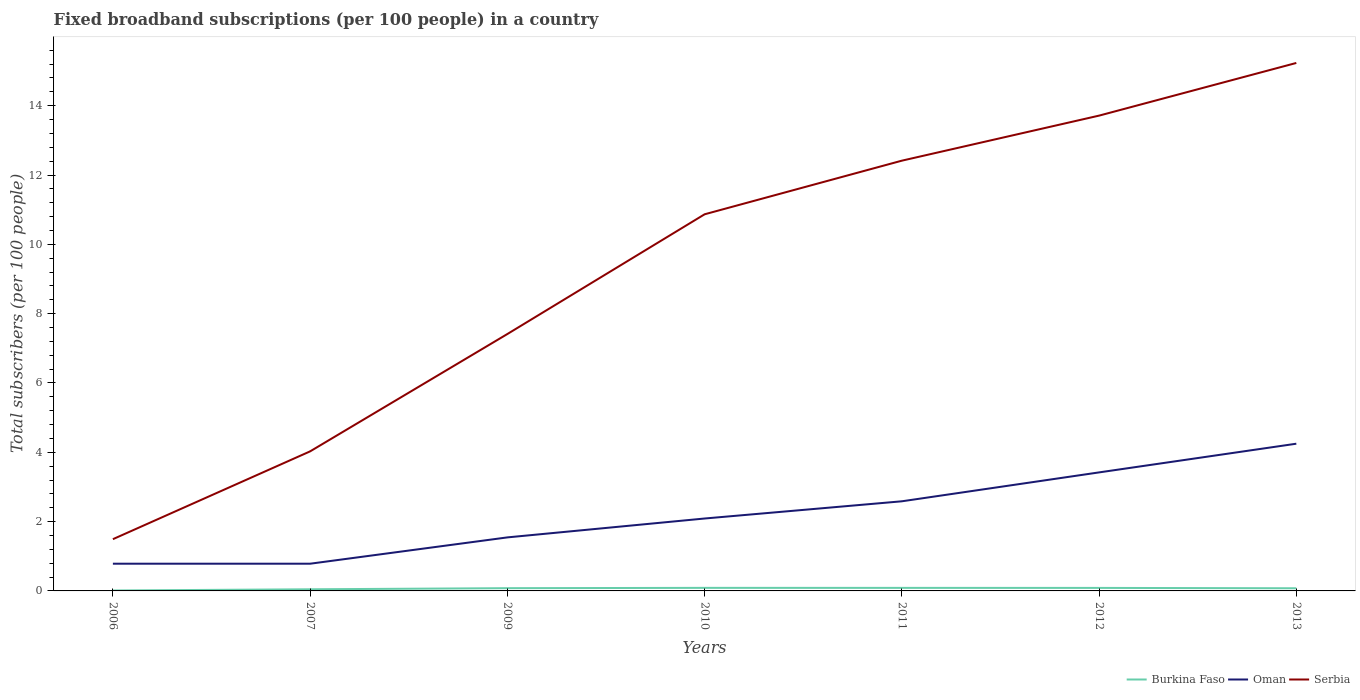How many different coloured lines are there?
Ensure brevity in your answer.  3. Across all years, what is the maximum number of broadband subscriptions in Burkina Faso?
Keep it short and to the point. 0.01. What is the total number of broadband subscriptions in Serbia in the graph?
Keep it short and to the point. -7.82. What is the difference between the highest and the second highest number of broadband subscriptions in Serbia?
Provide a short and direct response. 13.74. What is the difference between the highest and the lowest number of broadband subscriptions in Oman?
Offer a very short reply. 3. How many years are there in the graph?
Your answer should be very brief. 7. What is the difference between two consecutive major ticks on the Y-axis?
Your answer should be compact. 2. Are the values on the major ticks of Y-axis written in scientific E-notation?
Provide a succinct answer. No. Does the graph contain grids?
Ensure brevity in your answer.  No. How are the legend labels stacked?
Your answer should be very brief. Horizontal. What is the title of the graph?
Your answer should be very brief. Fixed broadband subscriptions (per 100 people) in a country. Does "Croatia" appear as one of the legend labels in the graph?
Your response must be concise. No. What is the label or title of the Y-axis?
Offer a terse response. Total subscribers (per 100 people). What is the Total subscribers (per 100 people) in Burkina Faso in 2006?
Your response must be concise. 0.01. What is the Total subscribers (per 100 people) of Oman in 2006?
Give a very brief answer. 0.79. What is the Total subscribers (per 100 people) of Serbia in 2006?
Give a very brief answer. 1.49. What is the Total subscribers (per 100 people) in Burkina Faso in 2007?
Your answer should be compact. 0.05. What is the Total subscribers (per 100 people) of Oman in 2007?
Offer a very short reply. 0.79. What is the Total subscribers (per 100 people) of Serbia in 2007?
Your answer should be very brief. 4.03. What is the Total subscribers (per 100 people) of Burkina Faso in 2009?
Provide a succinct answer. 0.08. What is the Total subscribers (per 100 people) in Oman in 2009?
Offer a terse response. 1.54. What is the Total subscribers (per 100 people) of Serbia in 2009?
Provide a short and direct response. 7.41. What is the Total subscribers (per 100 people) in Burkina Faso in 2010?
Provide a short and direct response. 0.09. What is the Total subscribers (per 100 people) of Oman in 2010?
Offer a terse response. 2.09. What is the Total subscribers (per 100 people) in Serbia in 2010?
Your answer should be very brief. 10.87. What is the Total subscribers (per 100 people) of Burkina Faso in 2011?
Provide a succinct answer. 0.09. What is the Total subscribers (per 100 people) of Oman in 2011?
Offer a very short reply. 2.59. What is the Total subscribers (per 100 people) of Serbia in 2011?
Ensure brevity in your answer.  12.41. What is the Total subscribers (per 100 people) in Burkina Faso in 2012?
Keep it short and to the point. 0.09. What is the Total subscribers (per 100 people) of Oman in 2012?
Your response must be concise. 3.42. What is the Total subscribers (per 100 people) in Serbia in 2012?
Your answer should be compact. 13.71. What is the Total subscribers (per 100 people) in Burkina Faso in 2013?
Give a very brief answer. 0.08. What is the Total subscribers (per 100 people) in Oman in 2013?
Make the answer very short. 4.25. What is the Total subscribers (per 100 people) in Serbia in 2013?
Give a very brief answer. 15.23. Across all years, what is the maximum Total subscribers (per 100 people) in Burkina Faso?
Provide a succinct answer. 0.09. Across all years, what is the maximum Total subscribers (per 100 people) of Oman?
Offer a very short reply. 4.25. Across all years, what is the maximum Total subscribers (per 100 people) of Serbia?
Provide a short and direct response. 15.23. Across all years, what is the minimum Total subscribers (per 100 people) of Burkina Faso?
Provide a short and direct response. 0.01. Across all years, what is the minimum Total subscribers (per 100 people) in Oman?
Keep it short and to the point. 0.79. Across all years, what is the minimum Total subscribers (per 100 people) in Serbia?
Make the answer very short. 1.49. What is the total Total subscribers (per 100 people) in Burkina Faso in the graph?
Provide a short and direct response. 0.48. What is the total Total subscribers (per 100 people) of Oman in the graph?
Offer a very short reply. 15.46. What is the total Total subscribers (per 100 people) in Serbia in the graph?
Ensure brevity in your answer.  65.16. What is the difference between the Total subscribers (per 100 people) in Burkina Faso in 2006 and that in 2007?
Keep it short and to the point. -0.03. What is the difference between the Total subscribers (per 100 people) of Serbia in 2006 and that in 2007?
Keep it short and to the point. -2.53. What is the difference between the Total subscribers (per 100 people) in Burkina Faso in 2006 and that in 2009?
Keep it short and to the point. -0.07. What is the difference between the Total subscribers (per 100 people) in Oman in 2006 and that in 2009?
Offer a terse response. -0.76. What is the difference between the Total subscribers (per 100 people) of Serbia in 2006 and that in 2009?
Offer a terse response. -5.92. What is the difference between the Total subscribers (per 100 people) in Burkina Faso in 2006 and that in 2010?
Provide a short and direct response. -0.08. What is the difference between the Total subscribers (per 100 people) in Oman in 2006 and that in 2010?
Offer a very short reply. -1.3. What is the difference between the Total subscribers (per 100 people) in Serbia in 2006 and that in 2010?
Your response must be concise. -9.37. What is the difference between the Total subscribers (per 100 people) of Burkina Faso in 2006 and that in 2011?
Your response must be concise. -0.08. What is the difference between the Total subscribers (per 100 people) in Oman in 2006 and that in 2011?
Your response must be concise. -1.8. What is the difference between the Total subscribers (per 100 people) in Serbia in 2006 and that in 2011?
Your answer should be very brief. -10.92. What is the difference between the Total subscribers (per 100 people) in Burkina Faso in 2006 and that in 2012?
Provide a short and direct response. -0.07. What is the difference between the Total subscribers (per 100 people) in Oman in 2006 and that in 2012?
Offer a terse response. -2.63. What is the difference between the Total subscribers (per 100 people) of Serbia in 2006 and that in 2012?
Provide a succinct answer. -12.22. What is the difference between the Total subscribers (per 100 people) in Burkina Faso in 2006 and that in 2013?
Provide a short and direct response. -0.06. What is the difference between the Total subscribers (per 100 people) in Oman in 2006 and that in 2013?
Give a very brief answer. -3.46. What is the difference between the Total subscribers (per 100 people) of Serbia in 2006 and that in 2013?
Give a very brief answer. -13.74. What is the difference between the Total subscribers (per 100 people) in Burkina Faso in 2007 and that in 2009?
Your response must be concise. -0.03. What is the difference between the Total subscribers (per 100 people) in Oman in 2007 and that in 2009?
Provide a short and direct response. -0.76. What is the difference between the Total subscribers (per 100 people) of Serbia in 2007 and that in 2009?
Offer a very short reply. -3.39. What is the difference between the Total subscribers (per 100 people) of Burkina Faso in 2007 and that in 2010?
Ensure brevity in your answer.  -0.04. What is the difference between the Total subscribers (per 100 people) of Oman in 2007 and that in 2010?
Your answer should be very brief. -1.3. What is the difference between the Total subscribers (per 100 people) in Serbia in 2007 and that in 2010?
Your answer should be compact. -6.84. What is the difference between the Total subscribers (per 100 people) in Burkina Faso in 2007 and that in 2011?
Make the answer very short. -0.04. What is the difference between the Total subscribers (per 100 people) in Oman in 2007 and that in 2011?
Provide a short and direct response. -1.8. What is the difference between the Total subscribers (per 100 people) of Serbia in 2007 and that in 2011?
Keep it short and to the point. -8.39. What is the difference between the Total subscribers (per 100 people) in Burkina Faso in 2007 and that in 2012?
Ensure brevity in your answer.  -0.04. What is the difference between the Total subscribers (per 100 people) in Oman in 2007 and that in 2012?
Ensure brevity in your answer.  -2.63. What is the difference between the Total subscribers (per 100 people) in Serbia in 2007 and that in 2012?
Provide a short and direct response. -9.69. What is the difference between the Total subscribers (per 100 people) of Burkina Faso in 2007 and that in 2013?
Provide a short and direct response. -0.03. What is the difference between the Total subscribers (per 100 people) of Oman in 2007 and that in 2013?
Your answer should be very brief. -3.46. What is the difference between the Total subscribers (per 100 people) of Serbia in 2007 and that in 2013?
Ensure brevity in your answer.  -11.21. What is the difference between the Total subscribers (per 100 people) in Burkina Faso in 2009 and that in 2010?
Provide a short and direct response. -0.01. What is the difference between the Total subscribers (per 100 people) of Oman in 2009 and that in 2010?
Keep it short and to the point. -0.54. What is the difference between the Total subscribers (per 100 people) in Serbia in 2009 and that in 2010?
Ensure brevity in your answer.  -3.45. What is the difference between the Total subscribers (per 100 people) in Burkina Faso in 2009 and that in 2011?
Ensure brevity in your answer.  -0.01. What is the difference between the Total subscribers (per 100 people) of Oman in 2009 and that in 2011?
Your response must be concise. -1.04. What is the difference between the Total subscribers (per 100 people) of Serbia in 2009 and that in 2011?
Offer a terse response. -5. What is the difference between the Total subscribers (per 100 people) of Burkina Faso in 2009 and that in 2012?
Your response must be concise. -0.01. What is the difference between the Total subscribers (per 100 people) in Oman in 2009 and that in 2012?
Provide a short and direct response. -1.88. What is the difference between the Total subscribers (per 100 people) of Serbia in 2009 and that in 2012?
Ensure brevity in your answer.  -6.3. What is the difference between the Total subscribers (per 100 people) in Burkina Faso in 2009 and that in 2013?
Provide a succinct answer. 0. What is the difference between the Total subscribers (per 100 people) of Oman in 2009 and that in 2013?
Make the answer very short. -2.7. What is the difference between the Total subscribers (per 100 people) of Serbia in 2009 and that in 2013?
Ensure brevity in your answer.  -7.82. What is the difference between the Total subscribers (per 100 people) of Oman in 2010 and that in 2011?
Offer a very short reply. -0.5. What is the difference between the Total subscribers (per 100 people) of Serbia in 2010 and that in 2011?
Offer a very short reply. -1.55. What is the difference between the Total subscribers (per 100 people) of Burkina Faso in 2010 and that in 2012?
Provide a short and direct response. 0. What is the difference between the Total subscribers (per 100 people) in Oman in 2010 and that in 2012?
Give a very brief answer. -1.33. What is the difference between the Total subscribers (per 100 people) in Serbia in 2010 and that in 2012?
Ensure brevity in your answer.  -2.85. What is the difference between the Total subscribers (per 100 people) in Burkina Faso in 2010 and that in 2013?
Offer a very short reply. 0.01. What is the difference between the Total subscribers (per 100 people) of Oman in 2010 and that in 2013?
Provide a succinct answer. -2.16. What is the difference between the Total subscribers (per 100 people) of Serbia in 2010 and that in 2013?
Your answer should be very brief. -4.37. What is the difference between the Total subscribers (per 100 people) in Burkina Faso in 2011 and that in 2012?
Offer a terse response. 0. What is the difference between the Total subscribers (per 100 people) of Oman in 2011 and that in 2012?
Ensure brevity in your answer.  -0.83. What is the difference between the Total subscribers (per 100 people) of Serbia in 2011 and that in 2012?
Offer a very short reply. -1.3. What is the difference between the Total subscribers (per 100 people) in Burkina Faso in 2011 and that in 2013?
Make the answer very short. 0.01. What is the difference between the Total subscribers (per 100 people) of Oman in 2011 and that in 2013?
Your answer should be compact. -1.66. What is the difference between the Total subscribers (per 100 people) of Serbia in 2011 and that in 2013?
Your answer should be very brief. -2.82. What is the difference between the Total subscribers (per 100 people) of Burkina Faso in 2012 and that in 2013?
Provide a short and direct response. 0.01. What is the difference between the Total subscribers (per 100 people) in Oman in 2012 and that in 2013?
Ensure brevity in your answer.  -0.83. What is the difference between the Total subscribers (per 100 people) of Serbia in 2012 and that in 2013?
Provide a short and direct response. -1.52. What is the difference between the Total subscribers (per 100 people) in Burkina Faso in 2006 and the Total subscribers (per 100 people) in Oman in 2007?
Keep it short and to the point. -0.77. What is the difference between the Total subscribers (per 100 people) in Burkina Faso in 2006 and the Total subscribers (per 100 people) in Serbia in 2007?
Your answer should be compact. -4.01. What is the difference between the Total subscribers (per 100 people) of Oman in 2006 and the Total subscribers (per 100 people) of Serbia in 2007?
Ensure brevity in your answer.  -3.24. What is the difference between the Total subscribers (per 100 people) of Burkina Faso in 2006 and the Total subscribers (per 100 people) of Oman in 2009?
Your response must be concise. -1.53. What is the difference between the Total subscribers (per 100 people) of Burkina Faso in 2006 and the Total subscribers (per 100 people) of Serbia in 2009?
Your answer should be compact. -7.4. What is the difference between the Total subscribers (per 100 people) of Oman in 2006 and the Total subscribers (per 100 people) of Serbia in 2009?
Provide a short and direct response. -6.63. What is the difference between the Total subscribers (per 100 people) in Burkina Faso in 2006 and the Total subscribers (per 100 people) in Oman in 2010?
Your answer should be very brief. -2.08. What is the difference between the Total subscribers (per 100 people) of Burkina Faso in 2006 and the Total subscribers (per 100 people) of Serbia in 2010?
Your answer should be very brief. -10.85. What is the difference between the Total subscribers (per 100 people) in Oman in 2006 and the Total subscribers (per 100 people) in Serbia in 2010?
Offer a very short reply. -10.08. What is the difference between the Total subscribers (per 100 people) of Burkina Faso in 2006 and the Total subscribers (per 100 people) of Oman in 2011?
Your response must be concise. -2.57. What is the difference between the Total subscribers (per 100 people) of Burkina Faso in 2006 and the Total subscribers (per 100 people) of Serbia in 2011?
Offer a terse response. -12.4. What is the difference between the Total subscribers (per 100 people) of Oman in 2006 and the Total subscribers (per 100 people) of Serbia in 2011?
Your answer should be very brief. -11.63. What is the difference between the Total subscribers (per 100 people) in Burkina Faso in 2006 and the Total subscribers (per 100 people) in Oman in 2012?
Offer a very short reply. -3.41. What is the difference between the Total subscribers (per 100 people) of Burkina Faso in 2006 and the Total subscribers (per 100 people) of Serbia in 2012?
Your answer should be compact. -13.7. What is the difference between the Total subscribers (per 100 people) of Oman in 2006 and the Total subscribers (per 100 people) of Serbia in 2012?
Offer a terse response. -12.93. What is the difference between the Total subscribers (per 100 people) of Burkina Faso in 2006 and the Total subscribers (per 100 people) of Oman in 2013?
Provide a succinct answer. -4.24. What is the difference between the Total subscribers (per 100 people) of Burkina Faso in 2006 and the Total subscribers (per 100 people) of Serbia in 2013?
Provide a short and direct response. -15.22. What is the difference between the Total subscribers (per 100 people) of Oman in 2006 and the Total subscribers (per 100 people) of Serbia in 2013?
Your response must be concise. -14.45. What is the difference between the Total subscribers (per 100 people) of Burkina Faso in 2007 and the Total subscribers (per 100 people) of Oman in 2009?
Offer a terse response. -1.5. What is the difference between the Total subscribers (per 100 people) in Burkina Faso in 2007 and the Total subscribers (per 100 people) in Serbia in 2009?
Provide a short and direct response. -7.36. What is the difference between the Total subscribers (per 100 people) of Oman in 2007 and the Total subscribers (per 100 people) of Serbia in 2009?
Provide a succinct answer. -6.63. What is the difference between the Total subscribers (per 100 people) of Burkina Faso in 2007 and the Total subscribers (per 100 people) of Oman in 2010?
Provide a succinct answer. -2.04. What is the difference between the Total subscribers (per 100 people) in Burkina Faso in 2007 and the Total subscribers (per 100 people) in Serbia in 2010?
Give a very brief answer. -10.82. What is the difference between the Total subscribers (per 100 people) in Oman in 2007 and the Total subscribers (per 100 people) in Serbia in 2010?
Provide a succinct answer. -10.08. What is the difference between the Total subscribers (per 100 people) of Burkina Faso in 2007 and the Total subscribers (per 100 people) of Oman in 2011?
Offer a terse response. -2.54. What is the difference between the Total subscribers (per 100 people) in Burkina Faso in 2007 and the Total subscribers (per 100 people) in Serbia in 2011?
Keep it short and to the point. -12.37. What is the difference between the Total subscribers (per 100 people) of Oman in 2007 and the Total subscribers (per 100 people) of Serbia in 2011?
Keep it short and to the point. -11.63. What is the difference between the Total subscribers (per 100 people) in Burkina Faso in 2007 and the Total subscribers (per 100 people) in Oman in 2012?
Ensure brevity in your answer.  -3.37. What is the difference between the Total subscribers (per 100 people) of Burkina Faso in 2007 and the Total subscribers (per 100 people) of Serbia in 2012?
Your response must be concise. -13.67. What is the difference between the Total subscribers (per 100 people) of Oman in 2007 and the Total subscribers (per 100 people) of Serbia in 2012?
Offer a very short reply. -12.93. What is the difference between the Total subscribers (per 100 people) of Burkina Faso in 2007 and the Total subscribers (per 100 people) of Oman in 2013?
Your response must be concise. -4.2. What is the difference between the Total subscribers (per 100 people) of Burkina Faso in 2007 and the Total subscribers (per 100 people) of Serbia in 2013?
Your response must be concise. -15.19. What is the difference between the Total subscribers (per 100 people) of Oman in 2007 and the Total subscribers (per 100 people) of Serbia in 2013?
Offer a terse response. -14.45. What is the difference between the Total subscribers (per 100 people) in Burkina Faso in 2009 and the Total subscribers (per 100 people) in Oman in 2010?
Ensure brevity in your answer.  -2.01. What is the difference between the Total subscribers (per 100 people) in Burkina Faso in 2009 and the Total subscribers (per 100 people) in Serbia in 2010?
Your response must be concise. -10.79. What is the difference between the Total subscribers (per 100 people) of Oman in 2009 and the Total subscribers (per 100 people) of Serbia in 2010?
Offer a very short reply. -9.32. What is the difference between the Total subscribers (per 100 people) of Burkina Faso in 2009 and the Total subscribers (per 100 people) of Oman in 2011?
Provide a short and direct response. -2.51. What is the difference between the Total subscribers (per 100 people) of Burkina Faso in 2009 and the Total subscribers (per 100 people) of Serbia in 2011?
Your answer should be very brief. -12.33. What is the difference between the Total subscribers (per 100 people) of Oman in 2009 and the Total subscribers (per 100 people) of Serbia in 2011?
Offer a terse response. -10.87. What is the difference between the Total subscribers (per 100 people) of Burkina Faso in 2009 and the Total subscribers (per 100 people) of Oman in 2012?
Offer a terse response. -3.34. What is the difference between the Total subscribers (per 100 people) in Burkina Faso in 2009 and the Total subscribers (per 100 people) in Serbia in 2012?
Give a very brief answer. -13.63. What is the difference between the Total subscribers (per 100 people) of Oman in 2009 and the Total subscribers (per 100 people) of Serbia in 2012?
Provide a short and direct response. -12.17. What is the difference between the Total subscribers (per 100 people) of Burkina Faso in 2009 and the Total subscribers (per 100 people) of Oman in 2013?
Your answer should be very brief. -4.17. What is the difference between the Total subscribers (per 100 people) in Burkina Faso in 2009 and the Total subscribers (per 100 people) in Serbia in 2013?
Keep it short and to the point. -15.15. What is the difference between the Total subscribers (per 100 people) of Oman in 2009 and the Total subscribers (per 100 people) of Serbia in 2013?
Your answer should be compact. -13.69. What is the difference between the Total subscribers (per 100 people) in Burkina Faso in 2010 and the Total subscribers (per 100 people) in Oman in 2011?
Your response must be concise. -2.5. What is the difference between the Total subscribers (per 100 people) in Burkina Faso in 2010 and the Total subscribers (per 100 people) in Serbia in 2011?
Your answer should be compact. -12.33. What is the difference between the Total subscribers (per 100 people) in Oman in 2010 and the Total subscribers (per 100 people) in Serbia in 2011?
Offer a very short reply. -10.32. What is the difference between the Total subscribers (per 100 people) of Burkina Faso in 2010 and the Total subscribers (per 100 people) of Oman in 2012?
Give a very brief answer. -3.33. What is the difference between the Total subscribers (per 100 people) of Burkina Faso in 2010 and the Total subscribers (per 100 people) of Serbia in 2012?
Provide a short and direct response. -13.62. What is the difference between the Total subscribers (per 100 people) of Oman in 2010 and the Total subscribers (per 100 people) of Serbia in 2012?
Your answer should be compact. -11.62. What is the difference between the Total subscribers (per 100 people) in Burkina Faso in 2010 and the Total subscribers (per 100 people) in Oman in 2013?
Offer a terse response. -4.16. What is the difference between the Total subscribers (per 100 people) of Burkina Faso in 2010 and the Total subscribers (per 100 people) of Serbia in 2013?
Provide a short and direct response. -15.14. What is the difference between the Total subscribers (per 100 people) of Oman in 2010 and the Total subscribers (per 100 people) of Serbia in 2013?
Your response must be concise. -13.14. What is the difference between the Total subscribers (per 100 people) in Burkina Faso in 2011 and the Total subscribers (per 100 people) in Oman in 2012?
Offer a terse response. -3.33. What is the difference between the Total subscribers (per 100 people) of Burkina Faso in 2011 and the Total subscribers (per 100 people) of Serbia in 2012?
Give a very brief answer. -13.63. What is the difference between the Total subscribers (per 100 people) in Oman in 2011 and the Total subscribers (per 100 people) in Serbia in 2012?
Your response must be concise. -11.13. What is the difference between the Total subscribers (per 100 people) in Burkina Faso in 2011 and the Total subscribers (per 100 people) in Oman in 2013?
Provide a short and direct response. -4.16. What is the difference between the Total subscribers (per 100 people) in Burkina Faso in 2011 and the Total subscribers (per 100 people) in Serbia in 2013?
Offer a terse response. -15.14. What is the difference between the Total subscribers (per 100 people) of Oman in 2011 and the Total subscribers (per 100 people) of Serbia in 2013?
Keep it short and to the point. -12.65. What is the difference between the Total subscribers (per 100 people) of Burkina Faso in 2012 and the Total subscribers (per 100 people) of Oman in 2013?
Provide a succinct answer. -4.16. What is the difference between the Total subscribers (per 100 people) in Burkina Faso in 2012 and the Total subscribers (per 100 people) in Serbia in 2013?
Your answer should be very brief. -15.15. What is the difference between the Total subscribers (per 100 people) in Oman in 2012 and the Total subscribers (per 100 people) in Serbia in 2013?
Provide a succinct answer. -11.81. What is the average Total subscribers (per 100 people) of Burkina Faso per year?
Make the answer very short. 0.07. What is the average Total subscribers (per 100 people) in Oman per year?
Make the answer very short. 2.21. What is the average Total subscribers (per 100 people) in Serbia per year?
Your answer should be very brief. 9.31. In the year 2006, what is the difference between the Total subscribers (per 100 people) of Burkina Faso and Total subscribers (per 100 people) of Oman?
Provide a succinct answer. -0.77. In the year 2006, what is the difference between the Total subscribers (per 100 people) in Burkina Faso and Total subscribers (per 100 people) in Serbia?
Your answer should be very brief. -1.48. In the year 2006, what is the difference between the Total subscribers (per 100 people) of Oman and Total subscribers (per 100 people) of Serbia?
Make the answer very short. -0.71. In the year 2007, what is the difference between the Total subscribers (per 100 people) in Burkina Faso and Total subscribers (per 100 people) in Oman?
Your answer should be very brief. -0.74. In the year 2007, what is the difference between the Total subscribers (per 100 people) of Burkina Faso and Total subscribers (per 100 people) of Serbia?
Keep it short and to the point. -3.98. In the year 2007, what is the difference between the Total subscribers (per 100 people) of Oman and Total subscribers (per 100 people) of Serbia?
Keep it short and to the point. -3.24. In the year 2009, what is the difference between the Total subscribers (per 100 people) in Burkina Faso and Total subscribers (per 100 people) in Oman?
Your answer should be compact. -1.47. In the year 2009, what is the difference between the Total subscribers (per 100 people) in Burkina Faso and Total subscribers (per 100 people) in Serbia?
Offer a very short reply. -7.33. In the year 2009, what is the difference between the Total subscribers (per 100 people) of Oman and Total subscribers (per 100 people) of Serbia?
Your answer should be very brief. -5.87. In the year 2010, what is the difference between the Total subscribers (per 100 people) in Burkina Faso and Total subscribers (per 100 people) in Oman?
Ensure brevity in your answer.  -2. In the year 2010, what is the difference between the Total subscribers (per 100 people) in Burkina Faso and Total subscribers (per 100 people) in Serbia?
Make the answer very short. -10.78. In the year 2010, what is the difference between the Total subscribers (per 100 people) of Oman and Total subscribers (per 100 people) of Serbia?
Make the answer very short. -8.78. In the year 2011, what is the difference between the Total subscribers (per 100 people) in Burkina Faso and Total subscribers (per 100 people) in Oman?
Keep it short and to the point. -2.5. In the year 2011, what is the difference between the Total subscribers (per 100 people) in Burkina Faso and Total subscribers (per 100 people) in Serbia?
Your answer should be compact. -12.33. In the year 2011, what is the difference between the Total subscribers (per 100 people) of Oman and Total subscribers (per 100 people) of Serbia?
Make the answer very short. -9.83. In the year 2012, what is the difference between the Total subscribers (per 100 people) in Burkina Faso and Total subscribers (per 100 people) in Oman?
Keep it short and to the point. -3.33. In the year 2012, what is the difference between the Total subscribers (per 100 people) of Burkina Faso and Total subscribers (per 100 people) of Serbia?
Your response must be concise. -13.63. In the year 2012, what is the difference between the Total subscribers (per 100 people) in Oman and Total subscribers (per 100 people) in Serbia?
Your response must be concise. -10.29. In the year 2013, what is the difference between the Total subscribers (per 100 people) in Burkina Faso and Total subscribers (per 100 people) in Oman?
Keep it short and to the point. -4.17. In the year 2013, what is the difference between the Total subscribers (per 100 people) in Burkina Faso and Total subscribers (per 100 people) in Serbia?
Provide a succinct answer. -15.16. In the year 2013, what is the difference between the Total subscribers (per 100 people) in Oman and Total subscribers (per 100 people) in Serbia?
Your answer should be compact. -10.99. What is the ratio of the Total subscribers (per 100 people) in Burkina Faso in 2006 to that in 2007?
Ensure brevity in your answer.  0.26. What is the ratio of the Total subscribers (per 100 people) in Serbia in 2006 to that in 2007?
Offer a very short reply. 0.37. What is the ratio of the Total subscribers (per 100 people) of Burkina Faso in 2006 to that in 2009?
Provide a succinct answer. 0.16. What is the ratio of the Total subscribers (per 100 people) in Oman in 2006 to that in 2009?
Provide a succinct answer. 0.51. What is the ratio of the Total subscribers (per 100 people) of Serbia in 2006 to that in 2009?
Make the answer very short. 0.2. What is the ratio of the Total subscribers (per 100 people) of Burkina Faso in 2006 to that in 2010?
Provide a succinct answer. 0.14. What is the ratio of the Total subscribers (per 100 people) of Oman in 2006 to that in 2010?
Provide a succinct answer. 0.38. What is the ratio of the Total subscribers (per 100 people) of Serbia in 2006 to that in 2010?
Provide a succinct answer. 0.14. What is the ratio of the Total subscribers (per 100 people) of Burkina Faso in 2006 to that in 2011?
Your answer should be very brief. 0.14. What is the ratio of the Total subscribers (per 100 people) of Oman in 2006 to that in 2011?
Your answer should be very brief. 0.3. What is the ratio of the Total subscribers (per 100 people) of Serbia in 2006 to that in 2011?
Make the answer very short. 0.12. What is the ratio of the Total subscribers (per 100 people) in Burkina Faso in 2006 to that in 2012?
Your response must be concise. 0.14. What is the ratio of the Total subscribers (per 100 people) in Oman in 2006 to that in 2012?
Offer a terse response. 0.23. What is the ratio of the Total subscribers (per 100 people) of Serbia in 2006 to that in 2012?
Your answer should be compact. 0.11. What is the ratio of the Total subscribers (per 100 people) in Burkina Faso in 2006 to that in 2013?
Keep it short and to the point. 0.16. What is the ratio of the Total subscribers (per 100 people) in Oman in 2006 to that in 2013?
Your response must be concise. 0.18. What is the ratio of the Total subscribers (per 100 people) in Serbia in 2006 to that in 2013?
Your answer should be compact. 0.1. What is the ratio of the Total subscribers (per 100 people) in Burkina Faso in 2007 to that in 2009?
Provide a succinct answer. 0.6. What is the ratio of the Total subscribers (per 100 people) in Oman in 2007 to that in 2009?
Your response must be concise. 0.51. What is the ratio of the Total subscribers (per 100 people) in Serbia in 2007 to that in 2009?
Your response must be concise. 0.54. What is the ratio of the Total subscribers (per 100 people) in Burkina Faso in 2007 to that in 2010?
Your answer should be very brief. 0.54. What is the ratio of the Total subscribers (per 100 people) of Oman in 2007 to that in 2010?
Provide a short and direct response. 0.38. What is the ratio of the Total subscribers (per 100 people) in Serbia in 2007 to that in 2010?
Provide a short and direct response. 0.37. What is the ratio of the Total subscribers (per 100 people) of Burkina Faso in 2007 to that in 2011?
Provide a succinct answer. 0.54. What is the ratio of the Total subscribers (per 100 people) of Oman in 2007 to that in 2011?
Offer a terse response. 0.3. What is the ratio of the Total subscribers (per 100 people) in Serbia in 2007 to that in 2011?
Give a very brief answer. 0.32. What is the ratio of the Total subscribers (per 100 people) of Burkina Faso in 2007 to that in 2012?
Provide a short and direct response. 0.54. What is the ratio of the Total subscribers (per 100 people) in Oman in 2007 to that in 2012?
Provide a short and direct response. 0.23. What is the ratio of the Total subscribers (per 100 people) in Serbia in 2007 to that in 2012?
Provide a short and direct response. 0.29. What is the ratio of the Total subscribers (per 100 people) of Burkina Faso in 2007 to that in 2013?
Keep it short and to the point. 0.62. What is the ratio of the Total subscribers (per 100 people) in Oman in 2007 to that in 2013?
Give a very brief answer. 0.18. What is the ratio of the Total subscribers (per 100 people) in Serbia in 2007 to that in 2013?
Provide a short and direct response. 0.26. What is the ratio of the Total subscribers (per 100 people) of Burkina Faso in 2009 to that in 2010?
Offer a terse response. 0.9. What is the ratio of the Total subscribers (per 100 people) in Oman in 2009 to that in 2010?
Ensure brevity in your answer.  0.74. What is the ratio of the Total subscribers (per 100 people) in Serbia in 2009 to that in 2010?
Your answer should be very brief. 0.68. What is the ratio of the Total subscribers (per 100 people) of Burkina Faso in 2009 to that in 2011?
Provide a succinct answer. 0.9. What is the ratio of the Total subscribers (per 100 people) of Oman in 2009 to that in 2011?
Keep it short and to the point. 0.6. What is the ratio of the Total subscribers (per 100 people) in Serbia in 2009 to that in 2011?
Ensure brevity in your answer.  0.6. What is the ratio of the Total subscribers (per 100 people) of Burkina Faso in 2009 to that in 2012?
Your answer should be compact. 0.91. What is the ratio of the Total subscribers (per 100 people) in Oman in 2009 to that in 2012?
Provide a succinct answer. 0.45. What is the ratio of the Total subscribers (per 100 people) of Serbia in 2009 to that in 2012?
Make the answer very short. 0.54. What is the ratio of the Total subscribers (per 100 people) of Burkina Faso in 2009 to that in 2013?
Offer a very short reply. 1.03. What is the ratio of the Total subscribers (per 100 people) of Oman in 2009 to that in 2013?
Offer a terse response. 0.36. What is the ratio of the Total subscribers (per 100 people) in Serbia in 2009 to that in 2013?
Provide a succinct answer. 0.49. What is the ratio of the Total subscribers (per 100 people) of Oman in 2010 to that in 2011?
Offer a very short reply. 0.81. What is the ratio of the Total subscribers (per 100 people) in Serbia in 2010 to that in 2011?
Your response must be concise. 0.88. What is the ratio of the Total subscribers (per 100 people) of Burkina Faso in 2010 to that in 2012?
Your answer should be very brief. 1.01. What is the ratio of the Total subscribers (per 100 people) of Oman in 2010 to that in 2012?
Keep it short and to the point. 0.61. What is the ratio of the Total subscribers (per 100 people) of Serbia in 2010 to that in 2012?
Offer a terse response. 0.79. What is the ratio of the Total subscribers (per 100 people) of Burkina Faso in 2010 to that in 2013?
Offer a very short reply. 1.15. What is the ratio of the Total subscribers (per 100 people) in Oman in 2010 to that in 2013?
Your answer should be compact. 0.49. What is the ratio of the Total subscribers (per 100 people) of Serbia in 2010 to that in 2013?
Make the answer very short. 0.71. What is the ratio of the Total subscribers (per 100 people) in Burkina Faso in 2011 to that in 2012?
Your answer should be compact. 1.01. What is the ratio of the Total subscribers (per 100 people) in Oman in 2011 to that in 2012?
Offer a very short reply. 0.76. What is the ratio of the Total subscribers (per 100 people) in Serbia in 2011 to that in 2012?
Provide a short and direct response. 0.91. What is the ratio of the Total subscribers (per 100 people) of Burkina Faso in 2011 to that in 2013?
Provide a succinct answer. 1.15. What is the ratio of the Total subscribers (per 100 people) of Oman in 2011 to that in 2013?
Keep it short and to the point. 0.61. What is the ratio of the Total subscribers (per 100 people) in Serbia in 2011 to that in 2013?
Your answer should be very brief. 0.81. What is the ratio of the Total subscribers (per 100 people) in Burkina Faso in 2012 to that in 2013?
Your response must be concise. 1.14. What is the ratio of the Total subscribers (per 100 people) in Oman in 2012 to that in 2013?
Provide a short and direct response. 0.81. What is the ratio of the Total subscribers (per 100 people) in Serbia in 2012 to that in 2013?
Provide a succinct answer. 0.9. What is the difference between the highest and the second highest Total subscribers (per 100 people) in Oman?
Give a very brief answer. 0.83. What is the difference between the highest and the second highest Total subscribers (per 100 people) of Serbia?
Your answer should be very brief. 1.52. What is the difference between the highest and the lowest Total subscribers (per 100 people) in Burkina Faso?
Keep it short and to the point. 0.08. What is the difference between the highest and the lowest Total subscribers (per 100 people) of Oman?
Your response must be concise. 3.46. What is the difference between the highest and the lowest Total subscribers (per 100 people) of Serbia?
Your answer should be very brief. 13.74. 